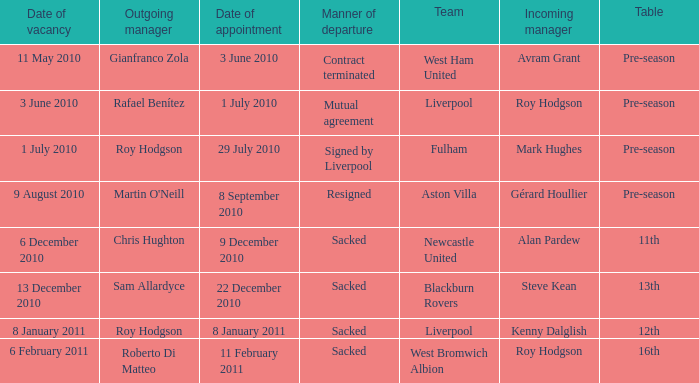What is the table for the team Blackburn Rovers? 13th. 